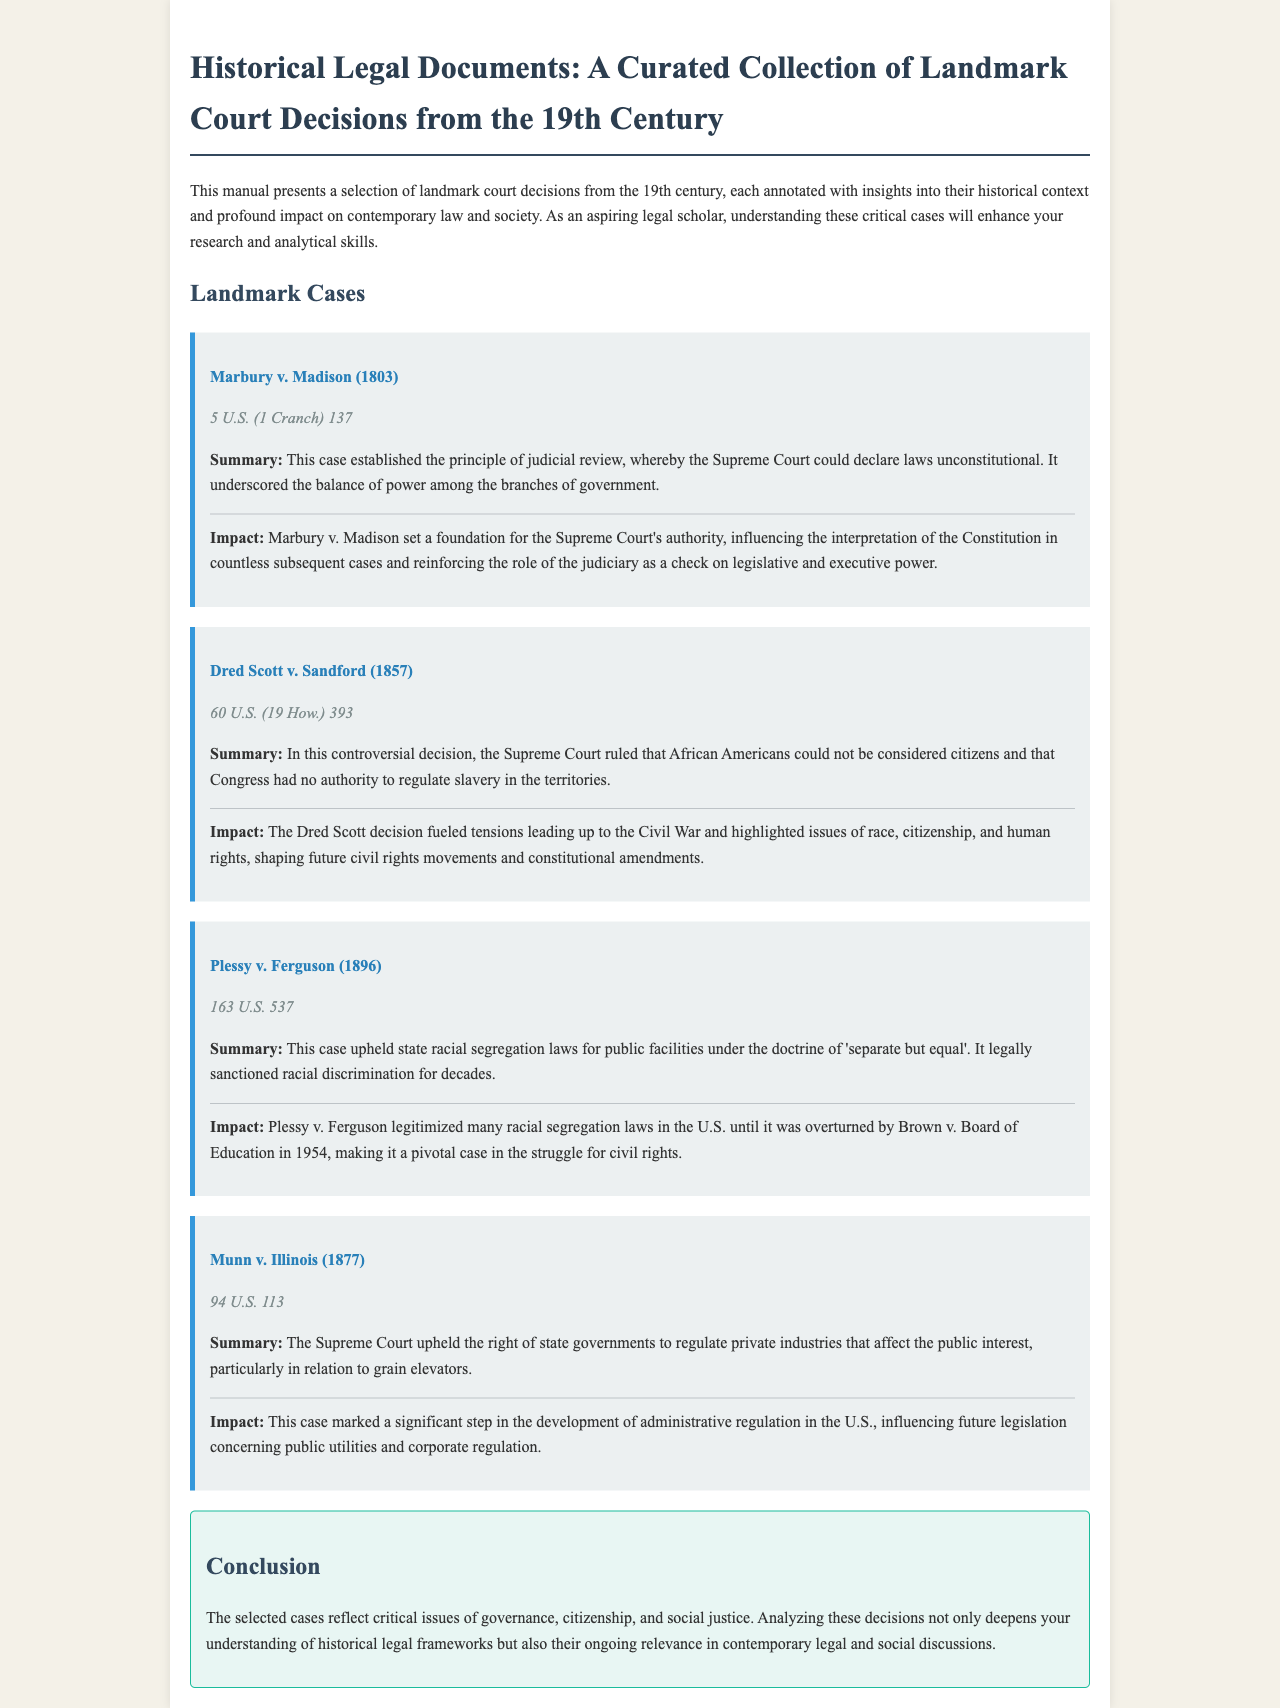What is the first landmark case mentioned? The document lists Marbury v. Madison as the first landmark case.
Answer: Marbury v. Madison In which year was Dred Scott v. Sandford decided? The decision for Dred Scott v. Sandford was made in 1857.
Answer: 1857 What legal principle was established in Marbury v. Madison? The case established the principle of judicial review.
Answer: Judicial review What was the outcome of Plessy v. Ferguson? Plessy v. Ferguson upheld state racial segregation laws for public facilities.
Answer: Upheld state racial segregation laws Which case is noted for its impact on administrative regulation? Munn v. Illinois is noted for its impact on administrative regulation.
Answer: Munn v. Illinois What problem did the Dred Scott decision highlight? The decision highlighted issues of race, citizenship, and human rights.
Answer: Race, citizenship, and human rights What term describes the doctrine upheld by Plessy v. Ferguson? The doctrine upheld was 'separate but equal'.
Answer: Separate but equal What does the conclusion of the document emphasize? The conclusion emphasizes the relevance of historical legal frameworks to contemporary discussions.
Answer: Relevance to contemporary discussions 